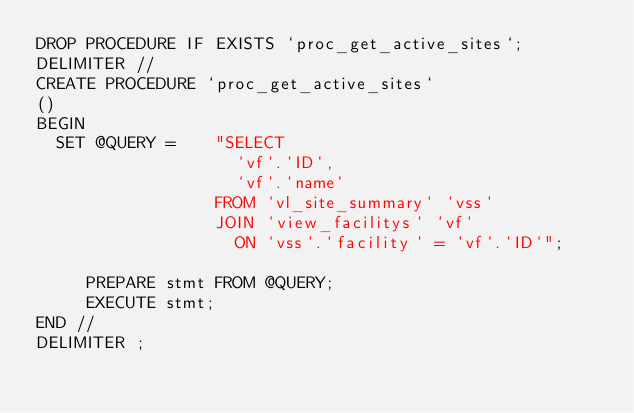<code> <loc_0><loc_0><loc_500><loc_500><_SQL_>DROP PROCEDURE IF EXISTS `proc_get_active_sites`;
DELIMITER //
CREATE PROCEDURE `proc_get_active_sites`
()
BEGIN
  SET @QUERY =    "SELECT 
                    `vf`.`ID`,
                    `vf`.`name` 
                  FROM `vl_site_summary` `vss` 
                  JOIN `view_facilitys` `vf` 
                    ON `vss`.`facility` = `vf`.`ID`";

     PREPARE stmt FROM @QUERY;
     EXECUTE stmt;
END //
DELIMITER ;
</code> 